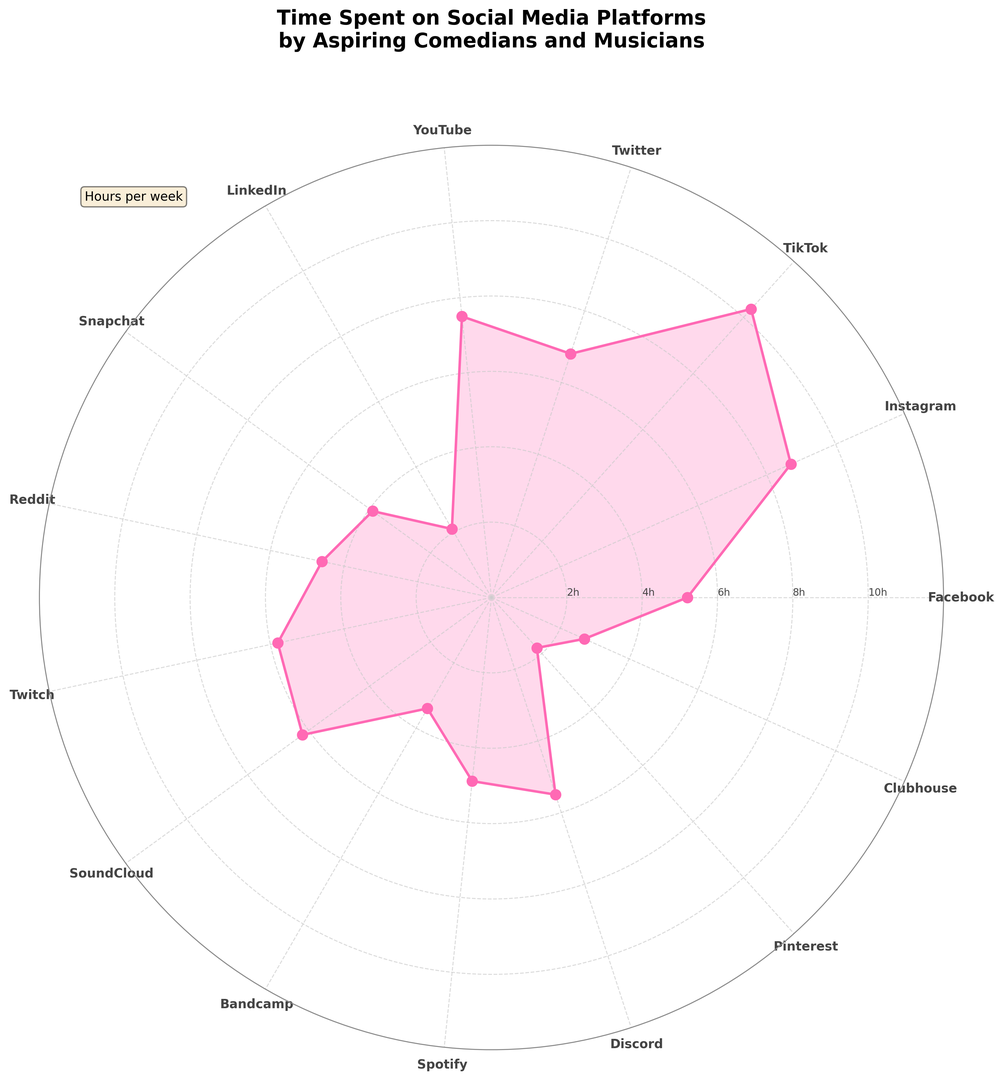What is the social media platform where aspiring comedians and musicians spend the most time? The platform with the highest value on the plot is TikTok, which peaks at around 10.3 hours per week.
Answer: TikTok Which two platforms have the closest time spent by aspiring comedians and musicians? Looking at the plot, Facebook and Spotify have nearly the same length radii, both close to around 5.2 and 4.9 hours per week.
Answer: Facebook and Spotify What is the total time spent on Instagram and YouTube by aspiring comedians and musicians? Instagram shows around 8.7 hours and YouTube shows around 7.5 hours. Adding these together: 8.7 + 7.5 = 16.2 hours.
Answer: 16.2 hours Which platforms do aspiring comedians and musicians spend less than 3 hours per week on? The radii for LinkedIn, Pinterest, and Clubhouse are all less than the 3-hour mark when visually analyzed.
Answer: LinkedIn, Pinterest, Clubhouse What is the average time spent on the four platforms with the least amount of usage? The platforms with the least amount of time are Pinterest (1.8 hours), LinkedIn (2.1 hours), Clubhouse (2.7 hours), and Bandcamp (3.4 hours). The average is: (1.8 + 2.1 + 2.7 + 3.4) / 4 = 2.5 hours.
Answer: 2.5 hours Which platform has a time spent that falls between the time spent on Facebook and Twitter, and what is that time spent? Facebook has 5.2 hours and Twitter has 6.8 hours. The time spent on Discord falls between these values at around 5.5 hours per week.
Answer: Discord, 5.5 hours How much more time do aspiring comedians and musicians spend on SoundCloud compared to Snapchat? SoundCloud’s time is around 6.2 hours and Snapchat’s time is around 3.9 hours. The difference is 6.2 - 3.9 = 2.3 hours.
Answer: 2.3 hours By how much do aspiring comedians and musicians spend more time on TikTok compared to LinkedIn? TikTok’s time is around 10.3 hours, and LinkedIn’s time is around 2.1 hours. The difference is 10.3 - 2.1 = 8.2 hours.
Answer: 8.2 hours Which platforms do aspiring comedians and musicians spend more than 6 hours per week on, and what are their respective times? TikTok (10.3 hours), Instagram (8.7 hours), YouTube (7.5 hours), Twitter (6.8 hours), and SoundCloud (6.2 hours) all have values greater than 6 hours per week.
Answer: TikTok: 10.3 hours, Instagram: 8.7 hours, YouTube: 7.5 hours, Twitter: 6.8 hours, SoundCloud: 6.2 hours Which platform has the median time spent and what is that value? Sorting the times in ascending order, the middle values are Pinterest: 1.8 hours, LinkedIn: 2.1 hours, Clubhouse: 2.7 hours, Bandcamp: 3.4 hours, Snapchat: 3.9 hours, Reddit: 4.6 hours, Spotify: 4.9 hours, Facebook: 5.2 hours, Twitch: 5.8 hours, Discord: 5.5 hours, SoundCloud: 6.2 hours, Twitter: 6.8 hours, YouTube: 7.5 hours, Instagram: 8.7 hours, TikTok: 10.3 hours. The median value is 5.2 hours (Facebook).
Answer: Facebook, 5.2 hours 